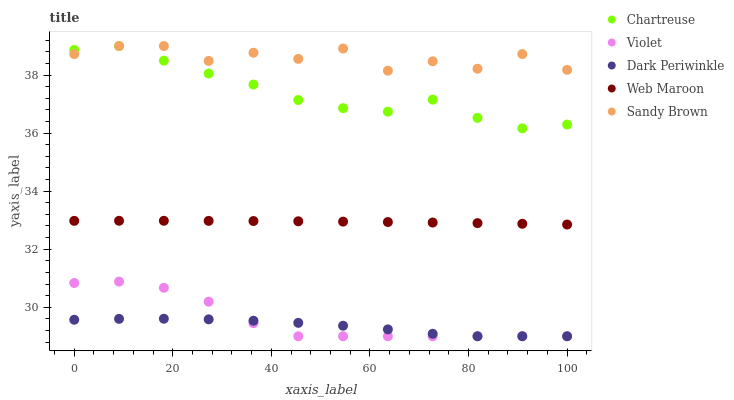Does Dark Periwinkle have the minimum area under the curve?
Answer yes or no. Yes. Does Sandy Brown have the maximum area under the curve?
Answer yes or no. Yes. Does Chartreuse have the minimum area under the curve?
Answer yes or no. No. Does Chartreuse have the maximum area under the curve?
Answer yes or no. No. Is Web Maroon the smoothest?
Answer yes or no. Yes. Is Sandy Brown the roughest?
Answer yes or no. Yes. Is Chartreuse the smoothest?
Answer yes or no. No. Is Chartreuse the roughest?
Answer yes or no. No. Does Dark Periwinkle have the lowest value?
Answer yes or no. Yes. Does Chartreuse have the lowest value?
Answer yes or no. No. Does Chartreuse have the highest value?
Answer yes or no. Yes. Does Web Maroon have the highest value?
Answer yes or no. No. Is Violet less than Web Maroon?
Answer yes or no. Yes. Is Chartreuse greater than Dark Periwinkle?
Answer yes or no. Yes. Does Violet intersect Dark Periwinkle?
Answer yes or no. Yes. Is Violet less than Dark Periwinkle?
Answer yes or no. No. Is Violet greater than Dark Periwinkle?
Answer yes or no. No. Does Violet intersect Web Maroon?
Answer yes or no. No. 